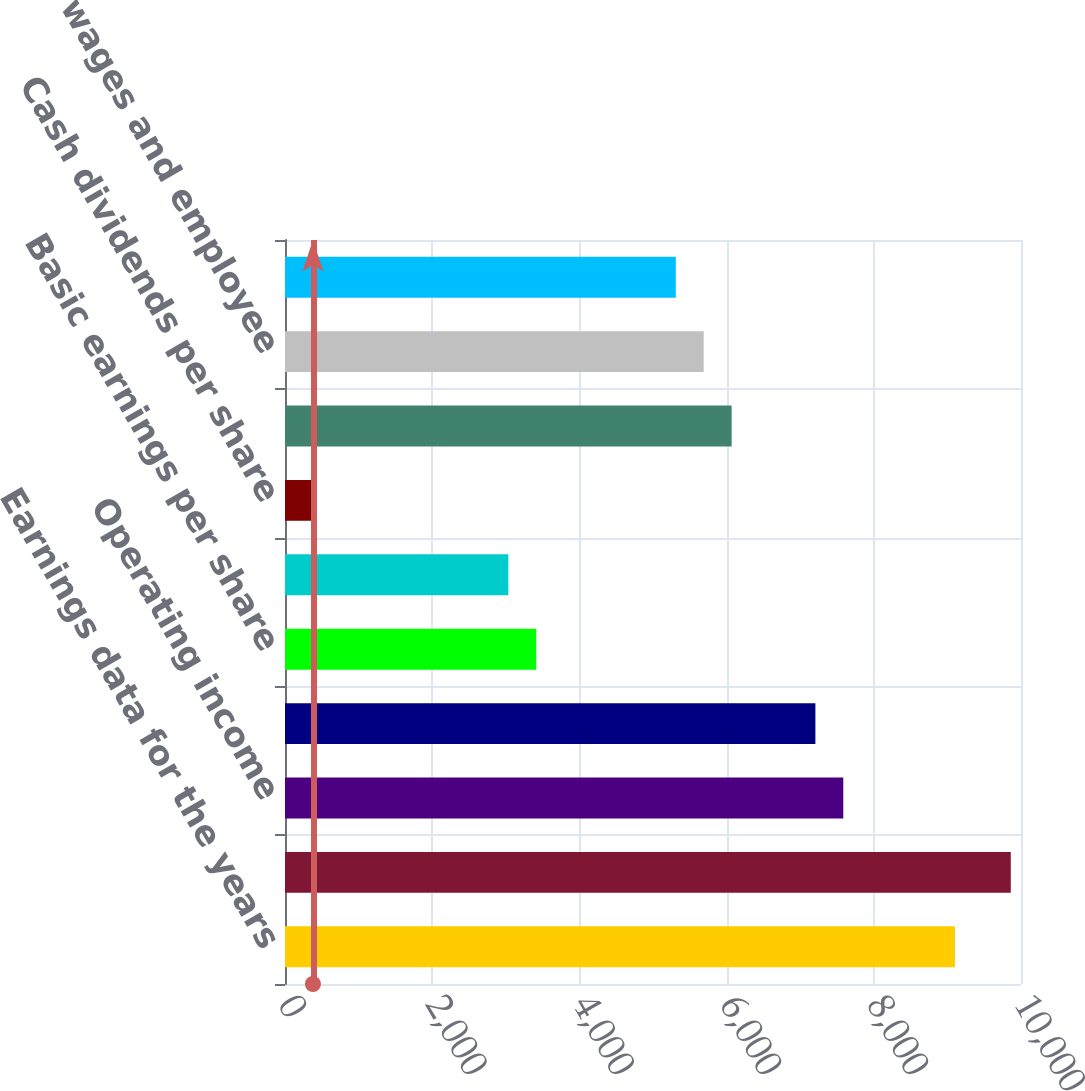Convert chart. <chart><loc_0><loc_0><loc_500><loc_500><bar_chart><fcel>Earnings data for the years<fcel>Operating revenues<fcel>Operating income<fcel>Net earnings<fcel>Basic earnings per share<fcel>Diluted earnings per share<fcel>Cash dividends per share<fcel>Rents and purchased<fcel>Salaries wages and employee<fcel>Fuel and fuel taxes<nl><fcel>9102.64<fcel>9861.16<fcel>7585.6<fcel>7206.34<fcel>3413.74<fcel>3034.48<fcel>379.66<fcel>6068.56<fcel>5689.3<fcel>5310.04<nl></chart> 